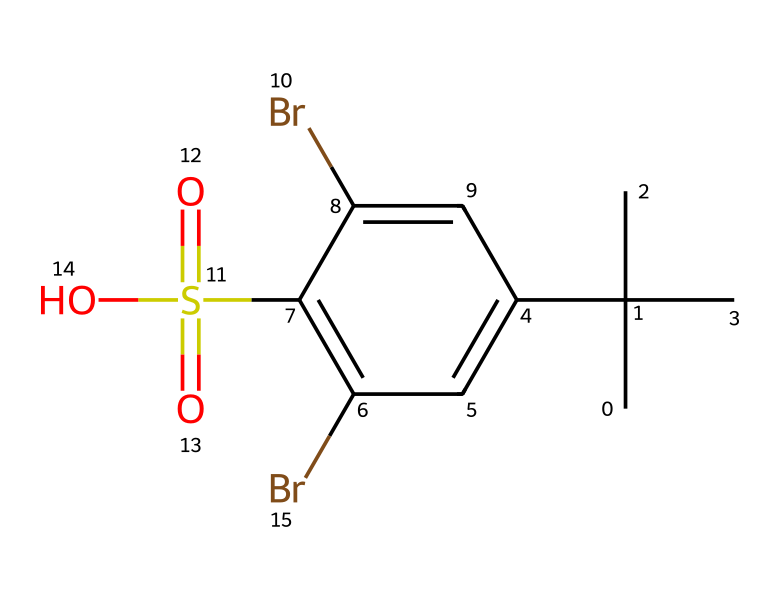What is the molecular formula of this chemical? To find the molecular formula, count each type of atom represented in the SMILES. The chemical has 10 carbons (C), 8 hydrogens (H), 2 bromines (Br), 1 sulfur (S), and 4 oxygens (O). Therefore, the molecular formula is C10H8Br2O4S.
Answer: C10H8Br2O4S How many oxygen atoms are present in this chemical? The SMILES representation indicates that there are four oxygen atoms (O) in the structure. This can be counted directly from the chemical representation.
Answer: 4 What type of functional group is present due to the sulfur atom? The sulfur atom is connected to two oxygen atoms with double bonds (S(=O)(=O)) and one hydroxyl group (S(=O)(=O)O), indicating that this compound contains a sulfonic acid group. This functional group typically involves a sulfur atom bonded to oxygen atoms.
Answer: sulfonic acid Which part of this chemical indicates its flame-retardant property? The presence of the sulfonic acid group and the bromine atoms in the structure suggests that it has flame-retardant properties, as bromine-containing compounds and sulfonic acids can inhibit combustion.
Answer: sulfonic acid and bromine atoms How many aromatic rings are present in this chemical? The chemical structure contains one aromatic ring (C1=CC(=C(...)), which indicates that it has a conjugated π-electron system typical of aromatic compounds. The ring can be identified by the alternating double bonds in the representation.
Answer: 1 What role do the bromine atoms play in the chemical's properties? The bromine atoms contribute to the flame retardancy of the chemical by releasing bromine radicals during combustion, which interrupt the flame propagation. This is a common feature of brominated compounds used in flame retardants.
Answer: interrupt flame propagation 